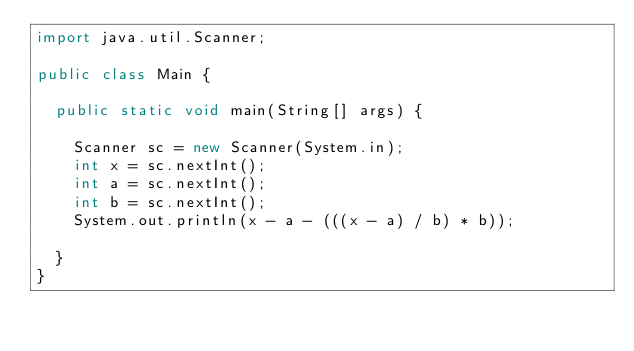Convert code to text. <code><loc_0><loc_0><loc_500><loc_500><_Java_>import java.util.Scanner;

public class Main {

  public static void main(String[] args) {

    Scanner sc = new Scanner(System.in);
    int x = sc.nextInt();
    int a = sc.nextInt();
    int b = sc.nextInt();
    System.out.println(x - a - (((x - a) / b) * b));

  }
}</code> 